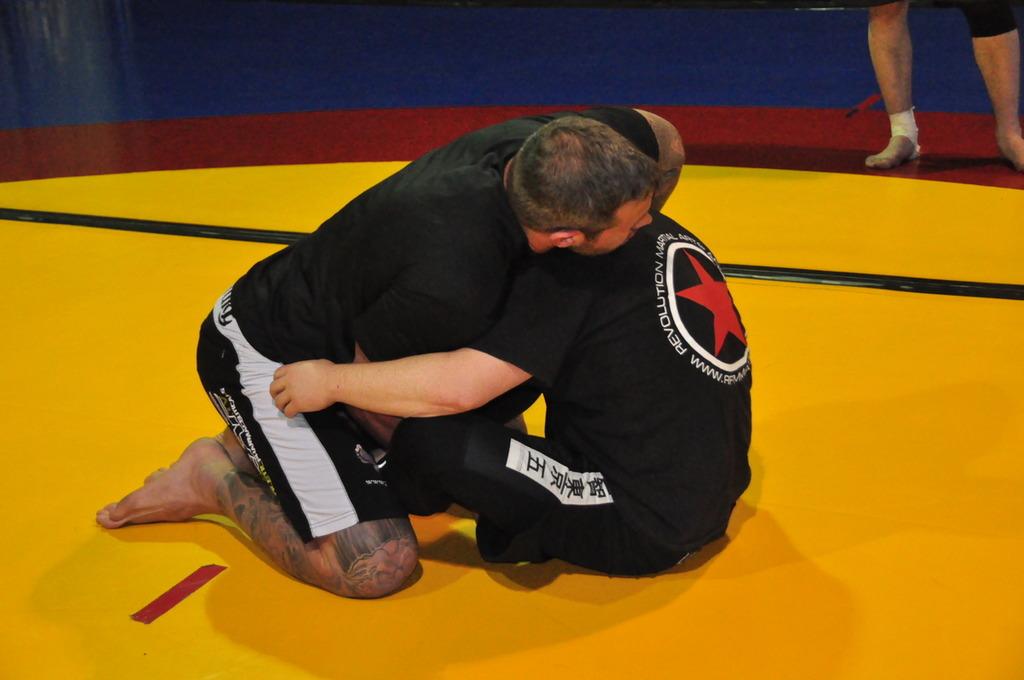Is revolution read on the back of the right man's shirt?
Provide a short and direct response. Yes. 